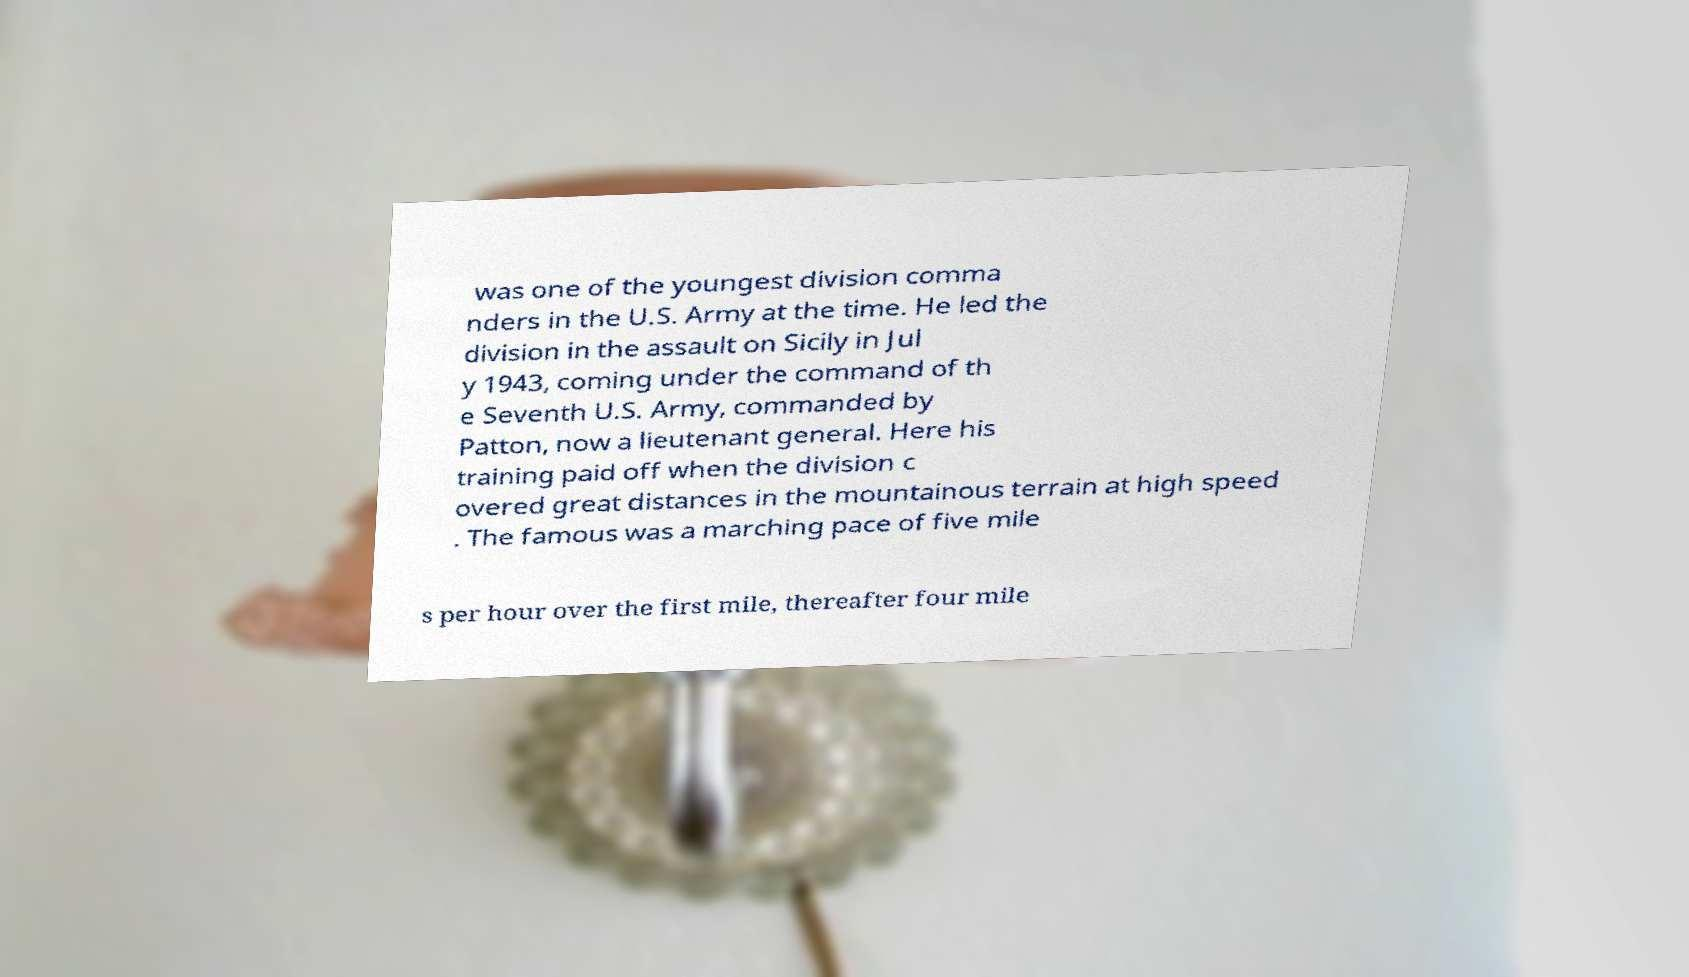Please identify and transcribe the text found in this image. was one of the youngest division comma nders in the U.S. Army at the time. He led the division in the assault on Sicily in Jul y 1943, coming under the command of th e Seventh U.S. Army, commanded by Patton, now a lieutenant general. Here his training paid off when the division c overed great distances in the mountainous terrain at high speed . The famous was a marching pace of five mile s per hour over the first mile, thereafter four mile 